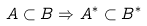<formula> <loc_0><loc_0><loc_500><loc_500>A \subset B \Rightarrow A ^ { * } \subset B ^ { * }</formula> 